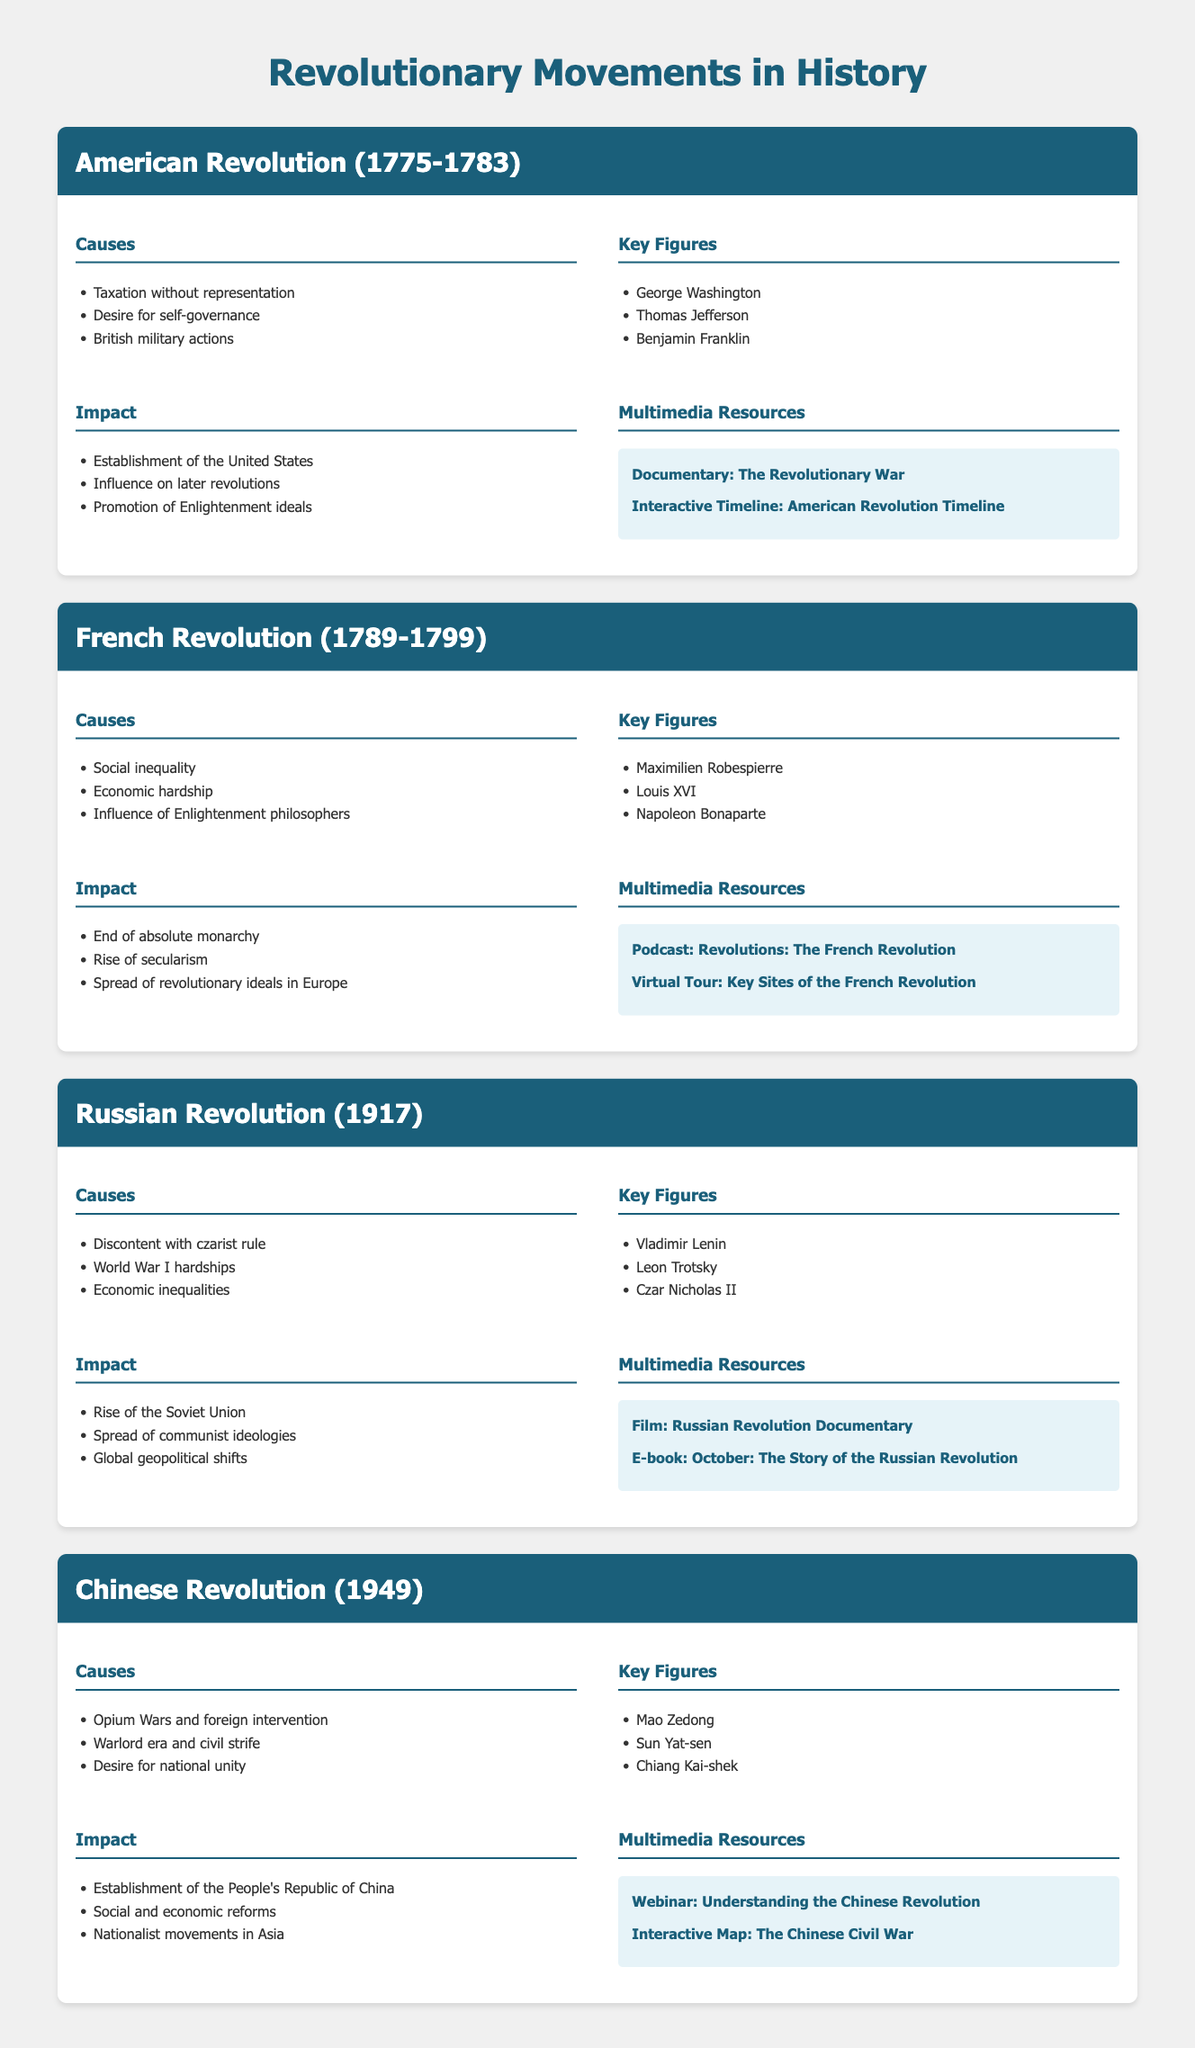What year did the American Revolution begin? The American Revolution started in 1775, as indicated in the document.
Answer: 1775 Who was a key figure in the French Revolution? Maxmilien Robespierre is listed as a key figure in the French Revolution in the catalog.
Answer: Maximilien Robespierre What was a cause of the Russian Revolution? The document specifically mentions "World War I hardships" as a cause of the Russian Revolution.
Answer: World War I hardships What impact did the Chinese Revolution have? The catalog states that one impact of the Chinese Revolution was the establishment of the People's Republic of China.
Answer: Establishment of the People's Republic of China How many key figures are listed for the American Revolution? The document lists three key figures for the American Revolution.
Answer: Three What is one multimedia resource linked to the French Revolution? The document describes a podcast titled "Revolutions: The French Revolution" as a multimedia resource.
Answer: Podcast: Revolutions: The French Revolution What was a significant impact of the Russian Revolution? The document mentions that the rise of the Soviet Union was a significant impact of the Russian Revolution.
Answer: Rise of the Soviet Union What social issue contributed to the French Revolution? The document lists "Social inequality" as a contributing factor to the French Revolution.
Answer: Social inequality In which years did the Chinese Revolution occur? The Chinese Revolution occurred in 1949, as noted in the document.
Answer: 1949 